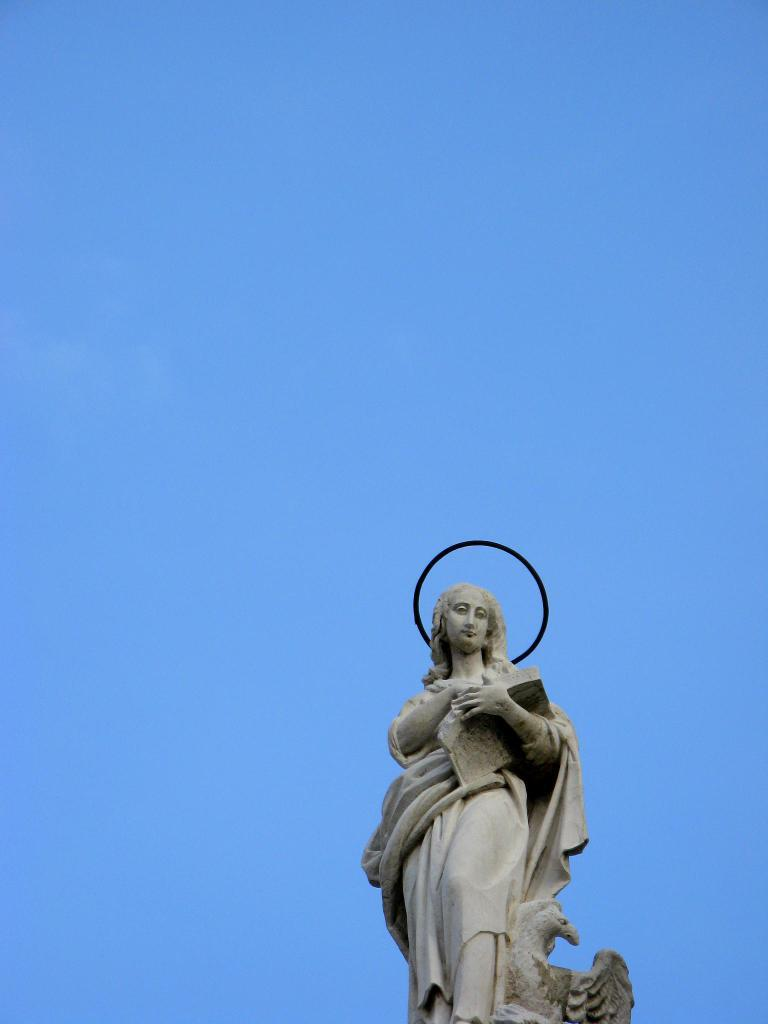What is the main subject of the image? There is a sculpture of a woman in the image. Can you describe the sculpture in more detail? Unfortunately, the provided facts do not offer any additional details about the sculpture. What might the sculpture be made of? The material used to create the sculpture is not mentioned in the given facts. How many pairs of socks are visible on the woman's feet in the image? There are no socks visible in the image, as it features a sculpture of a woman. 